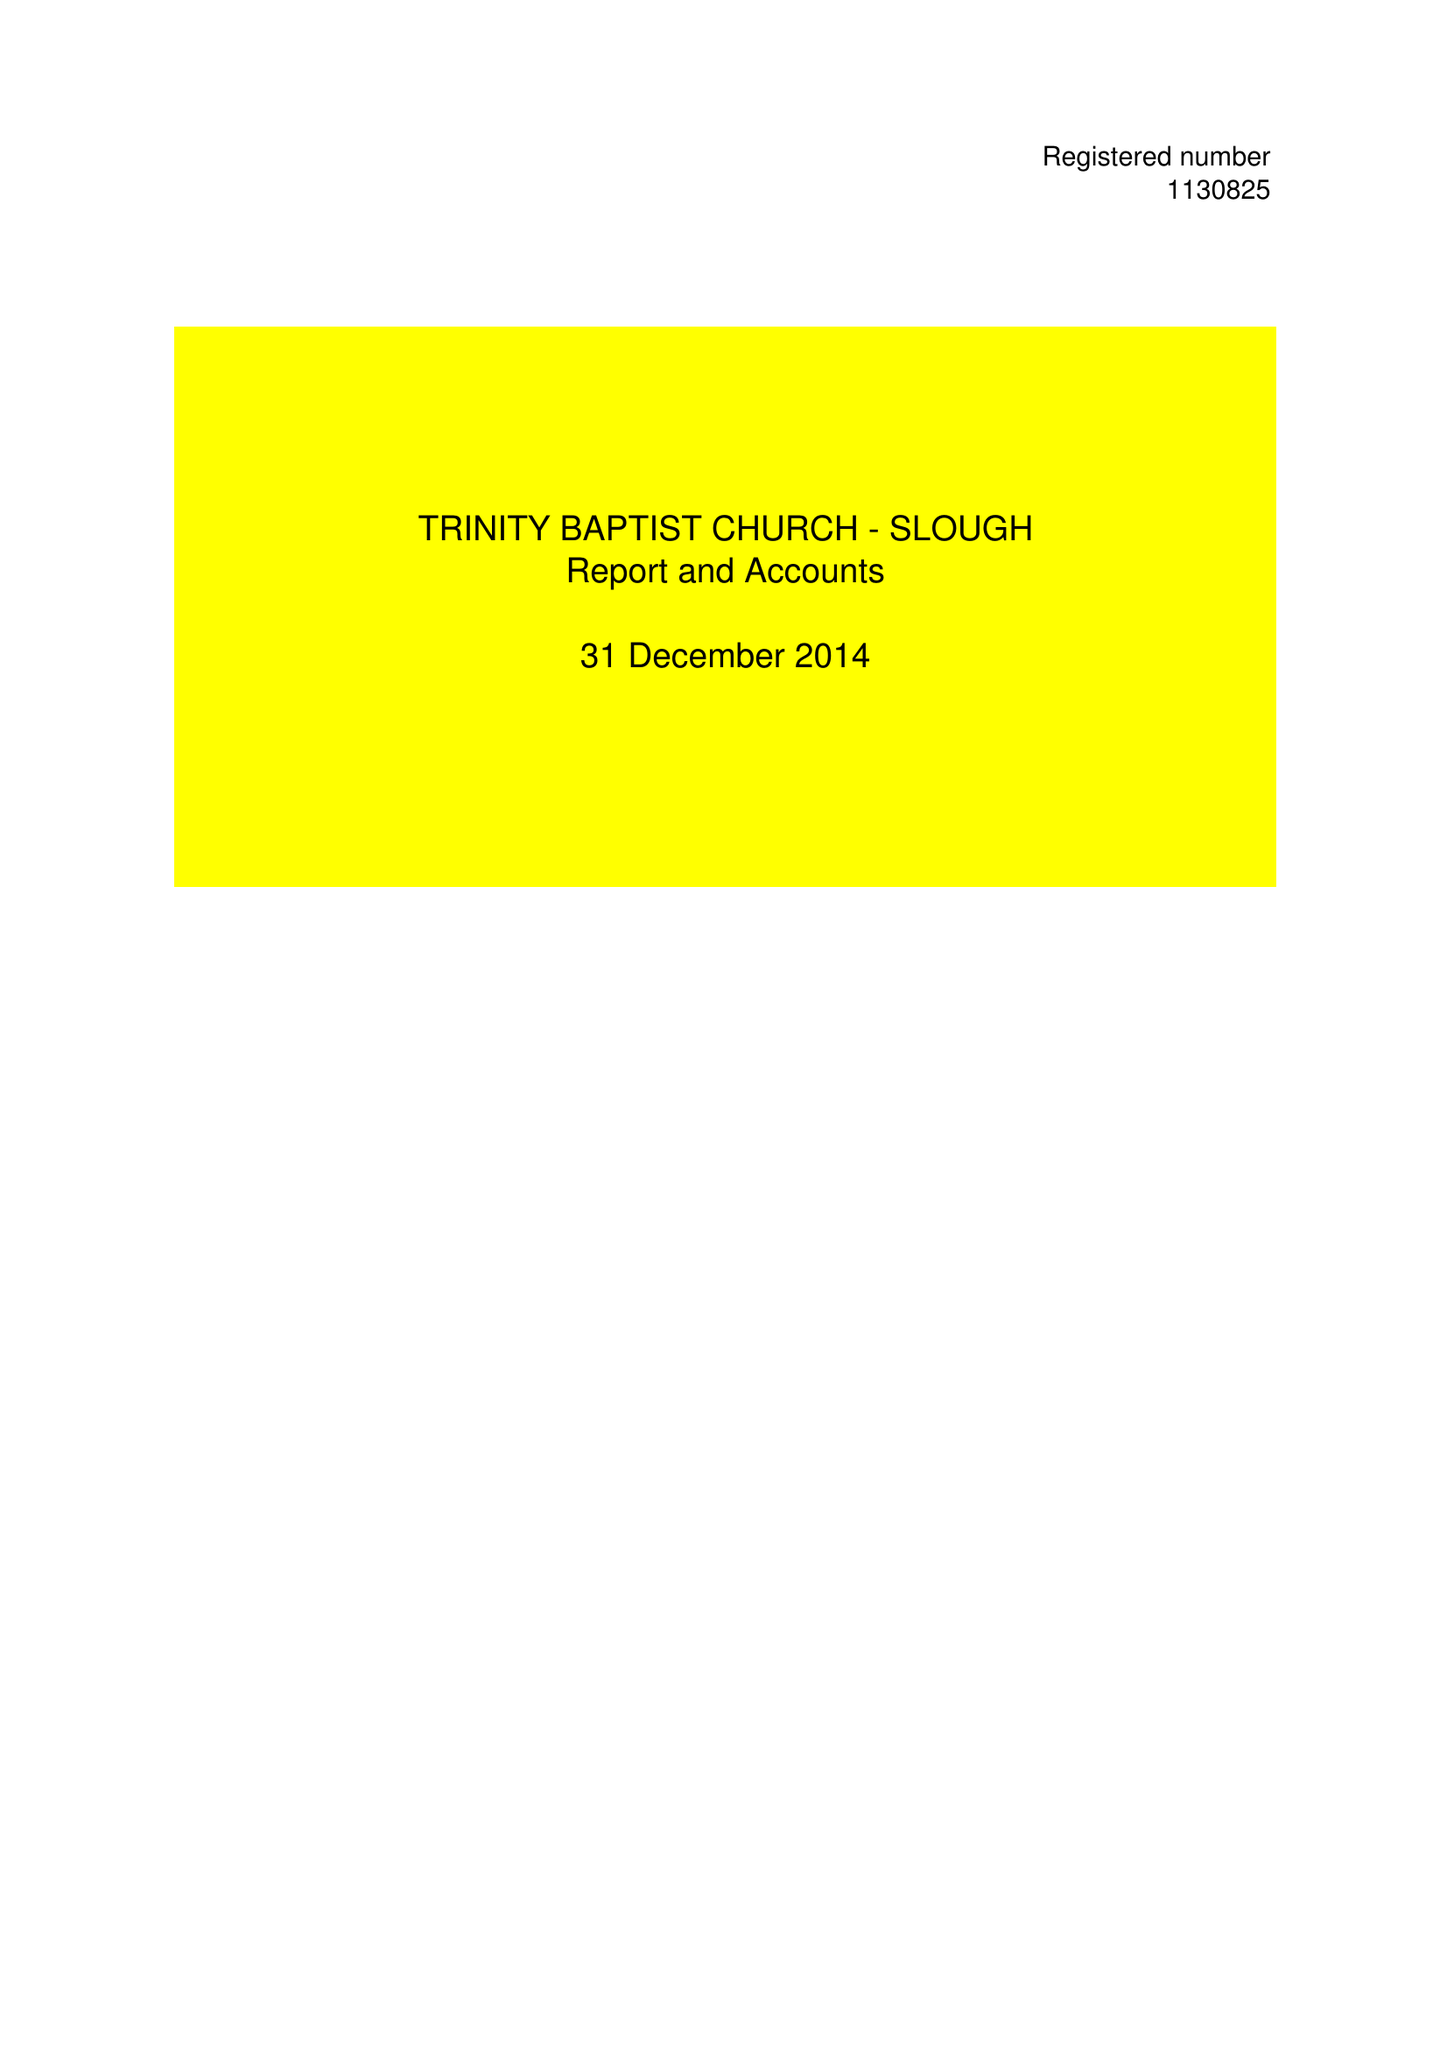What is the value for the charity_name?
Answer the question using a single word or phrase. Trinity Baptist Church - Slough 